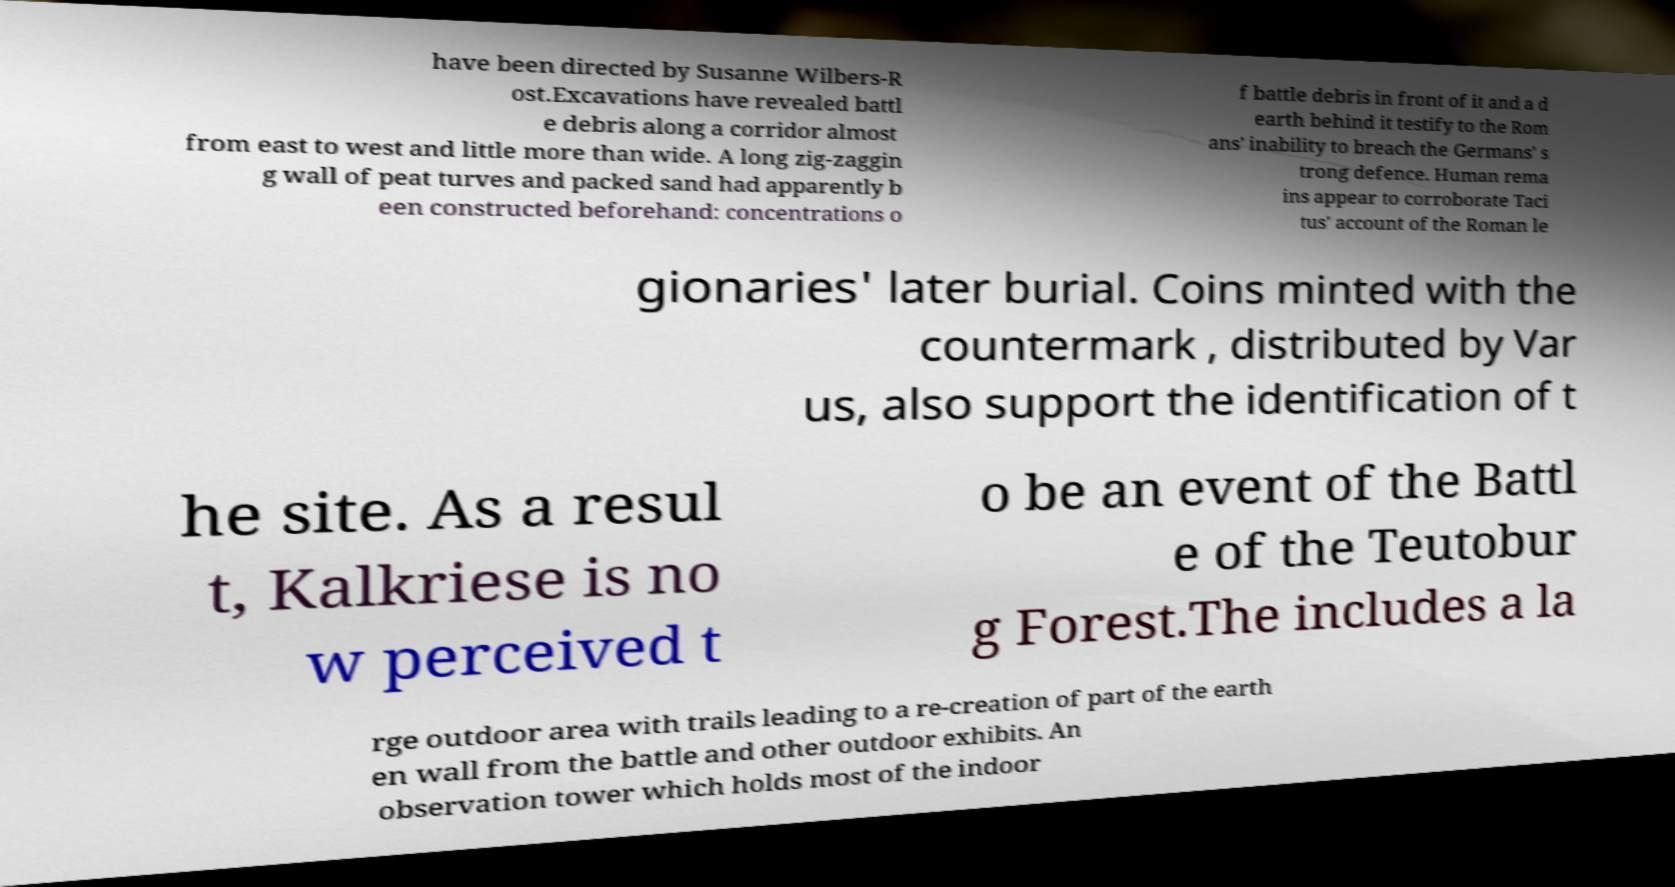I need the written content from this picture converted into text. Can you do that? have been directed by Susanne Wilbers-R ost.Excavations have revealed battl e debris along a corridor almost from east to west and little more than wide. A long zig-zaggin g wall of peat turves and packed sand had apparently b een constructed beforehand: concentrations o f battle debris in front of it and a d earth behind it testify to the Rom ans' inability to breach the Germans' s trong defence. Human rema ins appear to corroborate Taci tus' account of the Roman le gionaries' later burial. Coins minted with the countermark , distributed by Var us, also support the identification of t he site. As a resul t, Kalkriese is no w perceived t o be an event of the Battl e of the Teutobur g Forest.The includes a la rge outdoor area with trails leading to a re-creation of part of the earth en wall from the battle and other outdoor exhibits. An observation tower which holds most of the indoor 